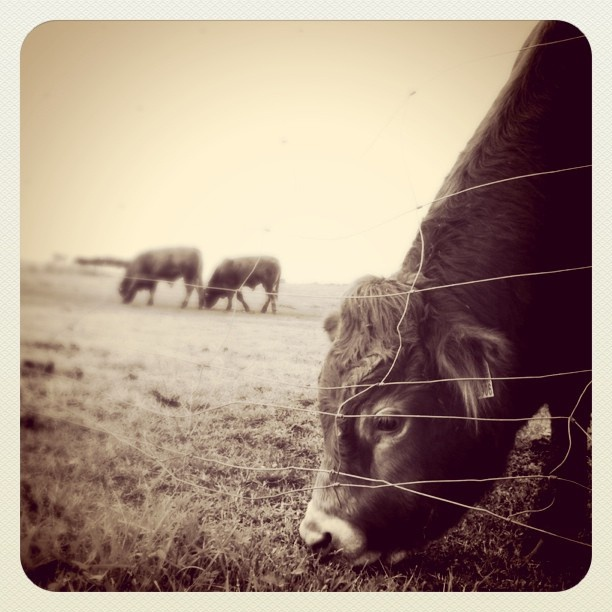Describe the objects in this image and their specific colors. I can see cow in ivory, black, maroon, brown, and gray tones, cow in ivory, brown, gray, and tan tones, and cow in ivory, brown, gray, maroon, and tan tones in this image. 